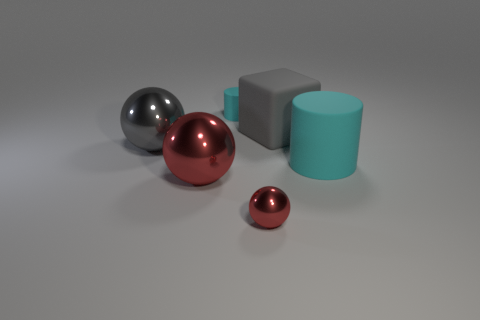There is a cyan matte thing behind the gray ball; is it the same size as the gray rubber thing?
Offer a very short reply. No. How many spheres are behind the cube behind the object that is in front of the big red shiny thing?
Keep it short and to the point. 0. How many purple things are large matte things or large objects?
Offer a terse response. 0. There is a large thing that is made of the same material as the large cube; what is its color?
Your response must be concise. Cyan. Is there any other thing that has the same size as the gray cube?
Your response must be concise. Yes. What number of small objects are cyan rubber objects or purple metal blocks?
Keep it short and to the point. 1. Is the number of large purple rubber spheres less than the number of tiny matte things?
Your response must be concise. Yes. What color is the other matte thing that is the same shape as the large cyan rubber object?
Provide a succinct answer. Cyan. Is there any other thing that is the same shape as the gray rubber object?
Keep it short and to the point. No. Are there more large cyan matte cylinders than big things?
Make the answer very short. No. 